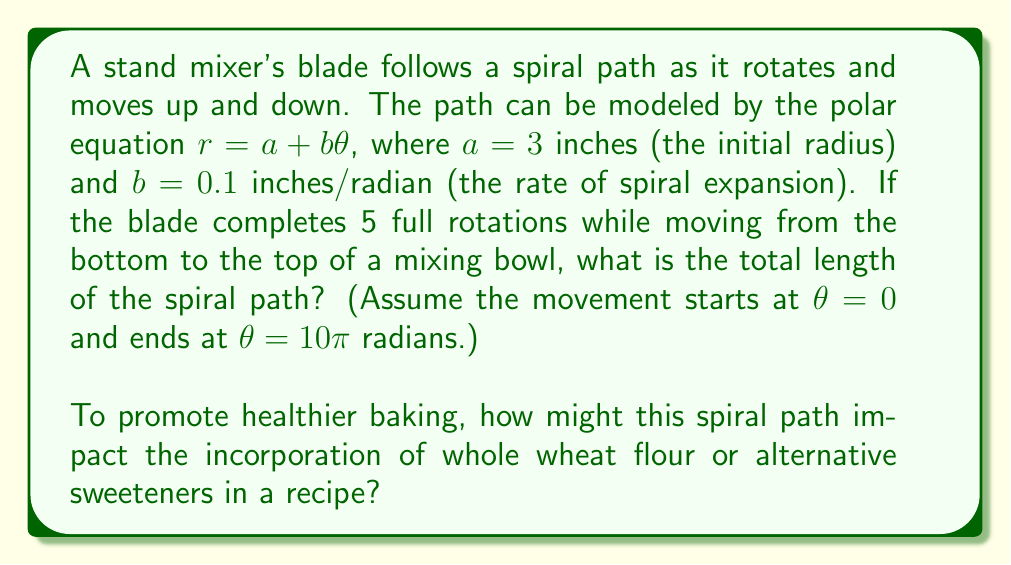Can you solve this math problem? To solve this problem, we need to use the formula for the arc length of a curve in polar coordinates and integrate it over the given interval. The steps are as follows:

1. The formula for the arc length of a curve in polar coordinates is:

   $$L = \int_{\theta_1}^{\theta_2} \sqrt{r^2 + \left(\frac{dr}{d\theta}\right)^2} d\theta$$

2. We are given $r = a + b\theta$, where $a = 3$ and $b = 0.1$. We need to find $\frac{dr}{d\theta}$:

   $$\frac{dr}{d\theta} = b = 0.1$$

3. Substituting these into the arc length formula:

   $$L = \int_{0}^{10\pi} \sqrt{(3 + 0.1\theta)^2 + (0.1)^2} d\theta$$

4. Simplify the integrand:

   $$L = \int_{0}^{10\pi} \sqrt{9 + 0.6\theta + 0.01\theta^2 + 0.01} d\theta$$
   $$L = \int_{0}^{10\pi} \sqrt{9.01 + 0.6\theta + 0.01\theta^2} d\theta$$

5. This integral doesn't have a simple analytical solution, so we need to use numerical integration methods to approximate the result. Using a computer algebra system or numerical integration tool, we can evaluate this integral.

6. The result of the numerical integration is approximately 35.4 inches.

The spiral path allows for efficient mixing by continuously folding ingredients into each other. For whole wheat flour, which is denser than all-purpose flour, this spiral motion helps incorporate it more evenly into the batter. For alternative sweeteners like stevia or monk fruit, which are often used in smaller quantities, the spiral ensures they are distributed uniformly throughout the mixture.
Answer: The total length of the spiral path is approximately 35.4 inches. 